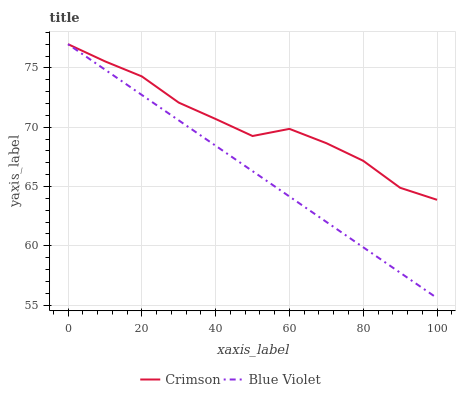Does Blue Violet have the minimum area under the curve?
Answer yes or no. Yes. Does Crimson have the maximum area under the curve?
Answer yes or no. Yes. Does Blue Violet have the maximum area under the curve?
Answer yes or no. No. Is Blue Violet the smoothest?
Answer yes or no. Yes. Is Crimson the roughest?
Answer yes or no. Yes. Is Blue Violet the roughest?
Answer yes or no. No. Does Blue Violet have the lowest value?
Answer yes or no. Yes. Does Blue Violet have the highest value?
Answer yes or no. Yes. Does Blue Violet intersect Crimson?
Answer yes or no. Yes. Is Blue Violet less than Crimson?
Answer yes or no. No. Is Blue Violet greater than Crimson?
Answer yes or no. No. 